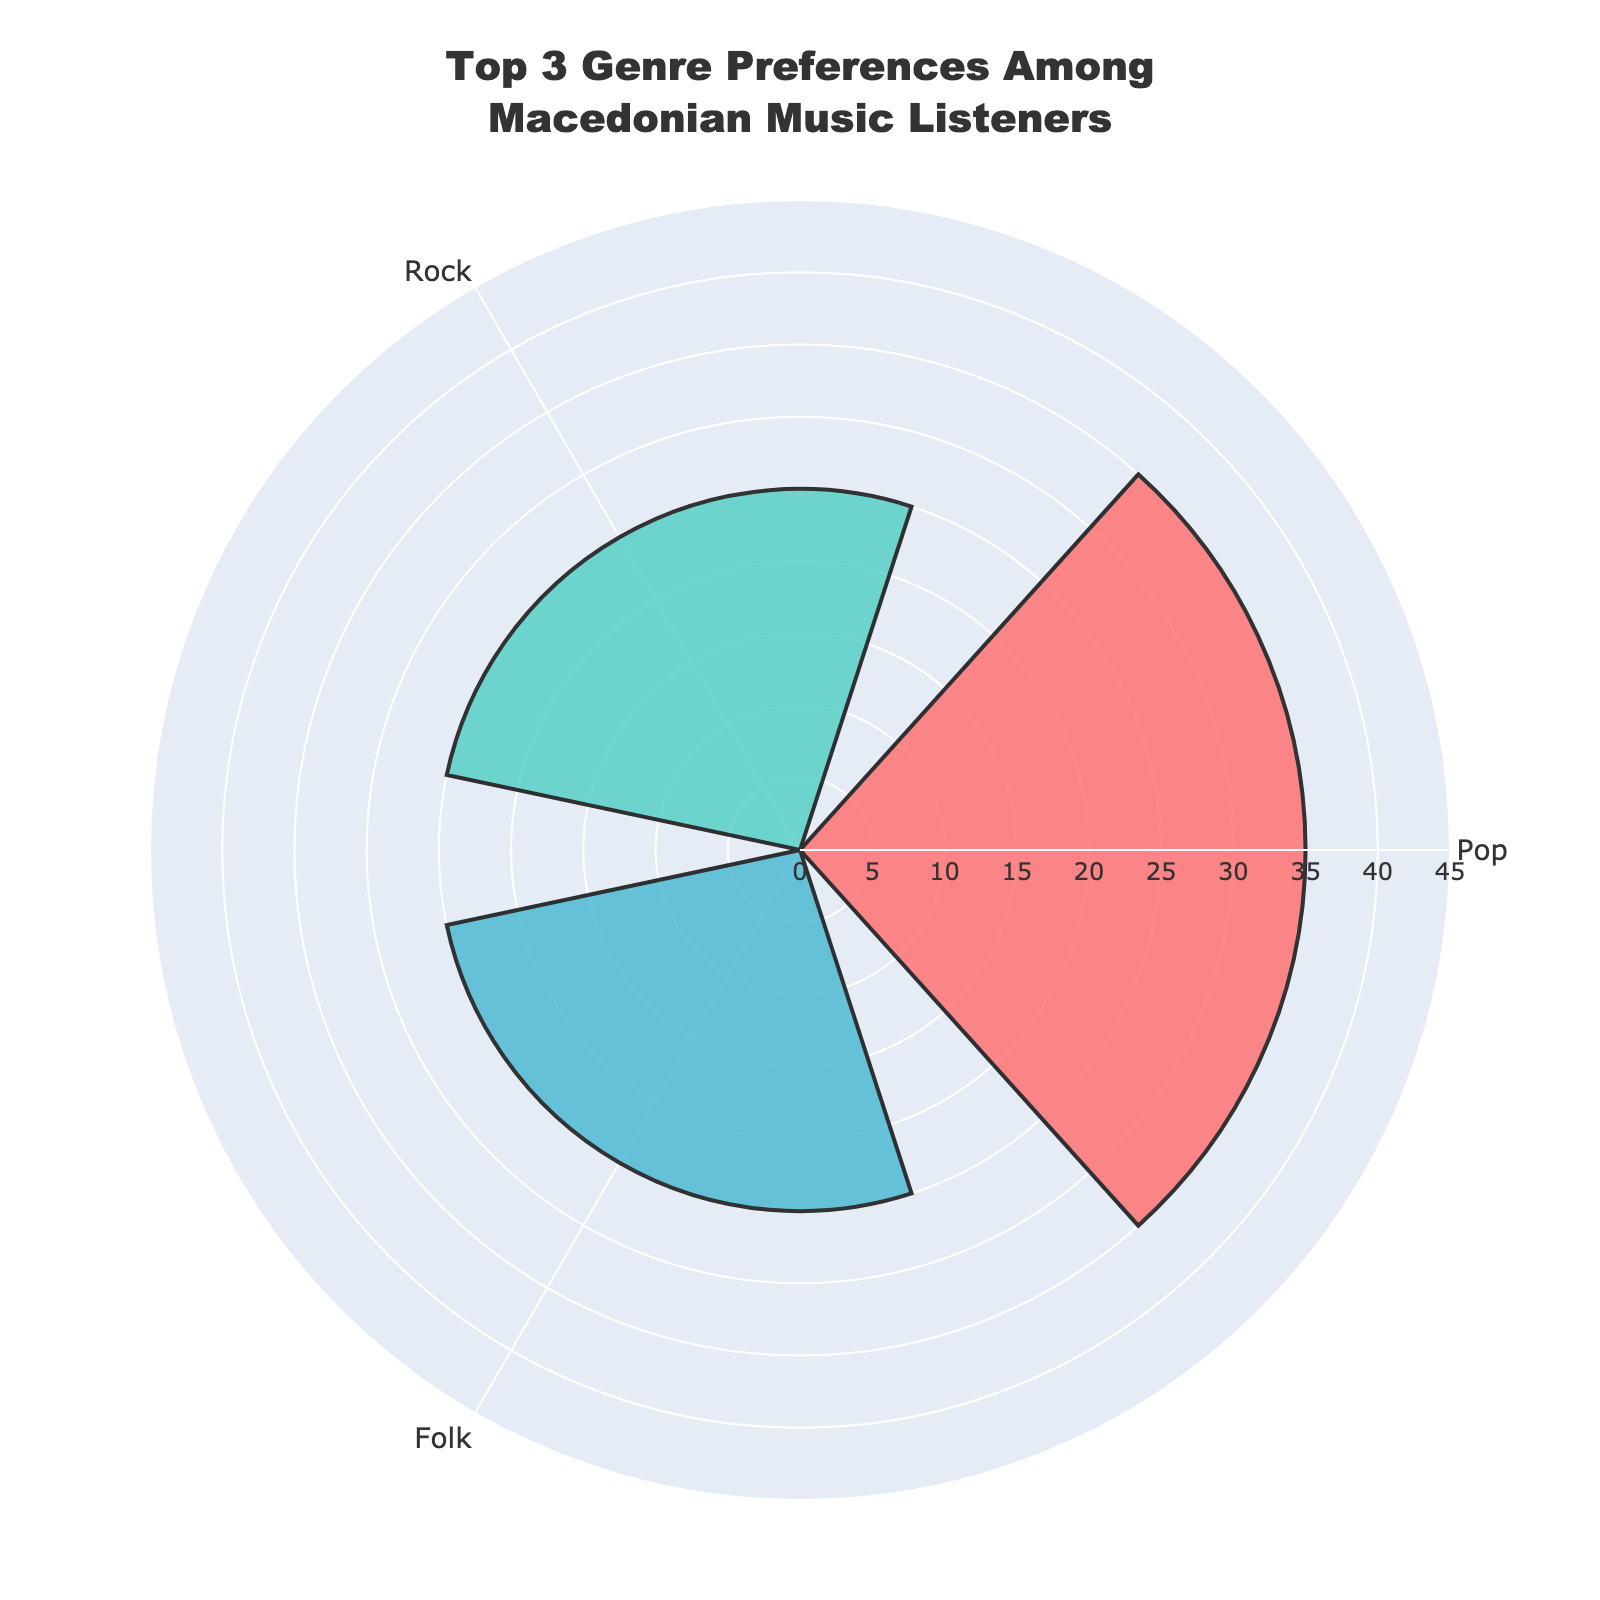What's the title of the figure? The title is displayed at the top of the figure and reads "Top 3 Genre Preferences Among Macedonian Music Listeners".
Answer: Top 3 Genre Preferences Among Macedonian Music Listeners How many genres are represented in the rose chart? The rose chart represents the top 3 genres among Macedonian music listeners. Three distinct sections with different colors indicate this.
Answer: 3 Which genre has the highest preference percentage in the rose chart? By observing the lengths of the radial bars, the one labeled "Pop" extends the furthest, indicating it has the highest preference percentage.
Answer: Pop What are the genres that have an equal percentage? The radial bars for "Rock" and "Folk" appear to extend to the same distance from the center, showing that they have identical preference percentages.
Answer: Rock and Folk What is the range of the radial axis in the rose chart? The radial axis is scaled from 0 to a value slightly higher than the highest percentage in the data to provide clear visual separation. The visible range extends from 0 to 45.
Answer: 0 to 45 What is the percentage difference between the least preferred and the most preferred genres in the rose chart? The least preferred genres among the top 3 are "Rock" and "Folk" at 25%, and "Pop" is the most preferred at 35%. Subtracting the least from the most results in a difference of 10%.
Answer: 10% Apart from the top 3 represented genres, which genre is not included in the rose chart? The data table shows four genres, but only the top 3 by percentage are in the rose chart. "Classical" is the genre not represented visually in the chart.
Answer: Classical What color represents the genre with the second highest preference? The radial bar for "Rock," the genre with the second highest preference (since it ties with "Folk"), is marked by the second color in the custom color scale. This color is a shade of teal.
Answer: Teal Which two genres have the same preference percentage, and what is that percentage? By viewing the radial bars, "Rock" and "Folk" appear to have bars of equal length. The data indicates they both have a preference percentage of 25%.
Answer: Rock and Folk, 25% What's the sum of the percentages for "Rock" and "Folk"? Adding the preference percentages for "Rock" and "Folk", which both are 25%, results in a sum of 50%.
Answer: 50% 